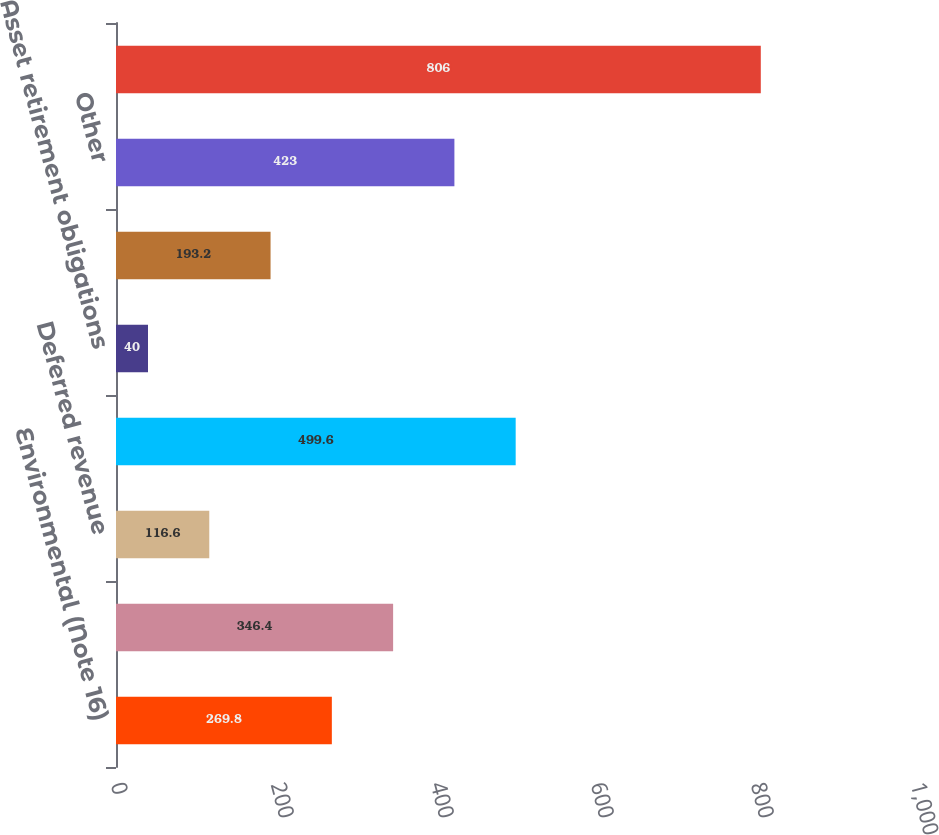Convert chart. <chart><loc_0><loc_0><loc_500><loc_500><bar_chart><fcel>Environmental (Note 16)<fcel>Insurance<fcel>Deferred revenue<fcel>Deferred proceeds (Note 4 Note<fcel>Asset retirement obligations<fcel>Derivatives<fcel>Other<fcel>Total<nl><fcel>269.8<fcel>346.4<fcel>116.6<fcel>499.6<fcel>40<fcel>193.2<fcel>423<fcel>806<nl></chart> 